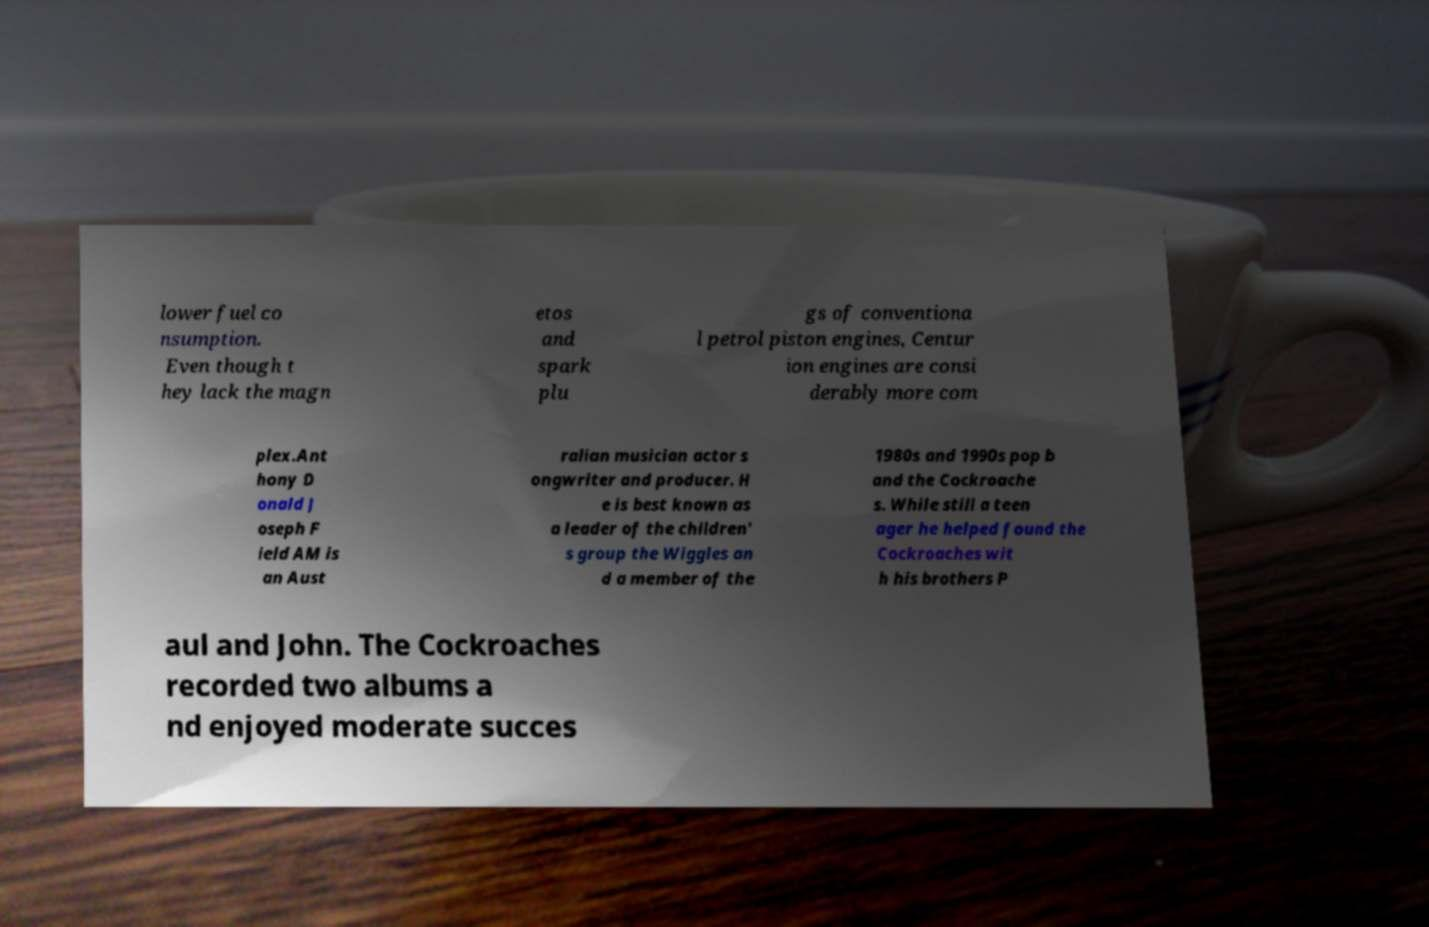What messages or text are displayed in this image? I need them in a readable, typed format. lower fuel co nsumption. Even though t hey lack the magn etos and spark plu gs of conventiona l petrol piston engines, Centur ion engines are consi derably more com plex.Ant hony D onald J oseph F ield AM is an Aust ralian musician actor s ongwriter and producer. H e is best known as a leader of the children' s group the Wiggles an d a member of the 1980s and 1990s pop b and the Cockroache s. While still a teen ager he helped found the Cockroaches wit h his brothers P aul and John. The Cockroaches recorded two albums a nd enjoyed moderate succes 